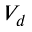Convert formula to latex. <formula><loc_0><loc_0><loc_500><loc_500>V _ { d }</formula> 